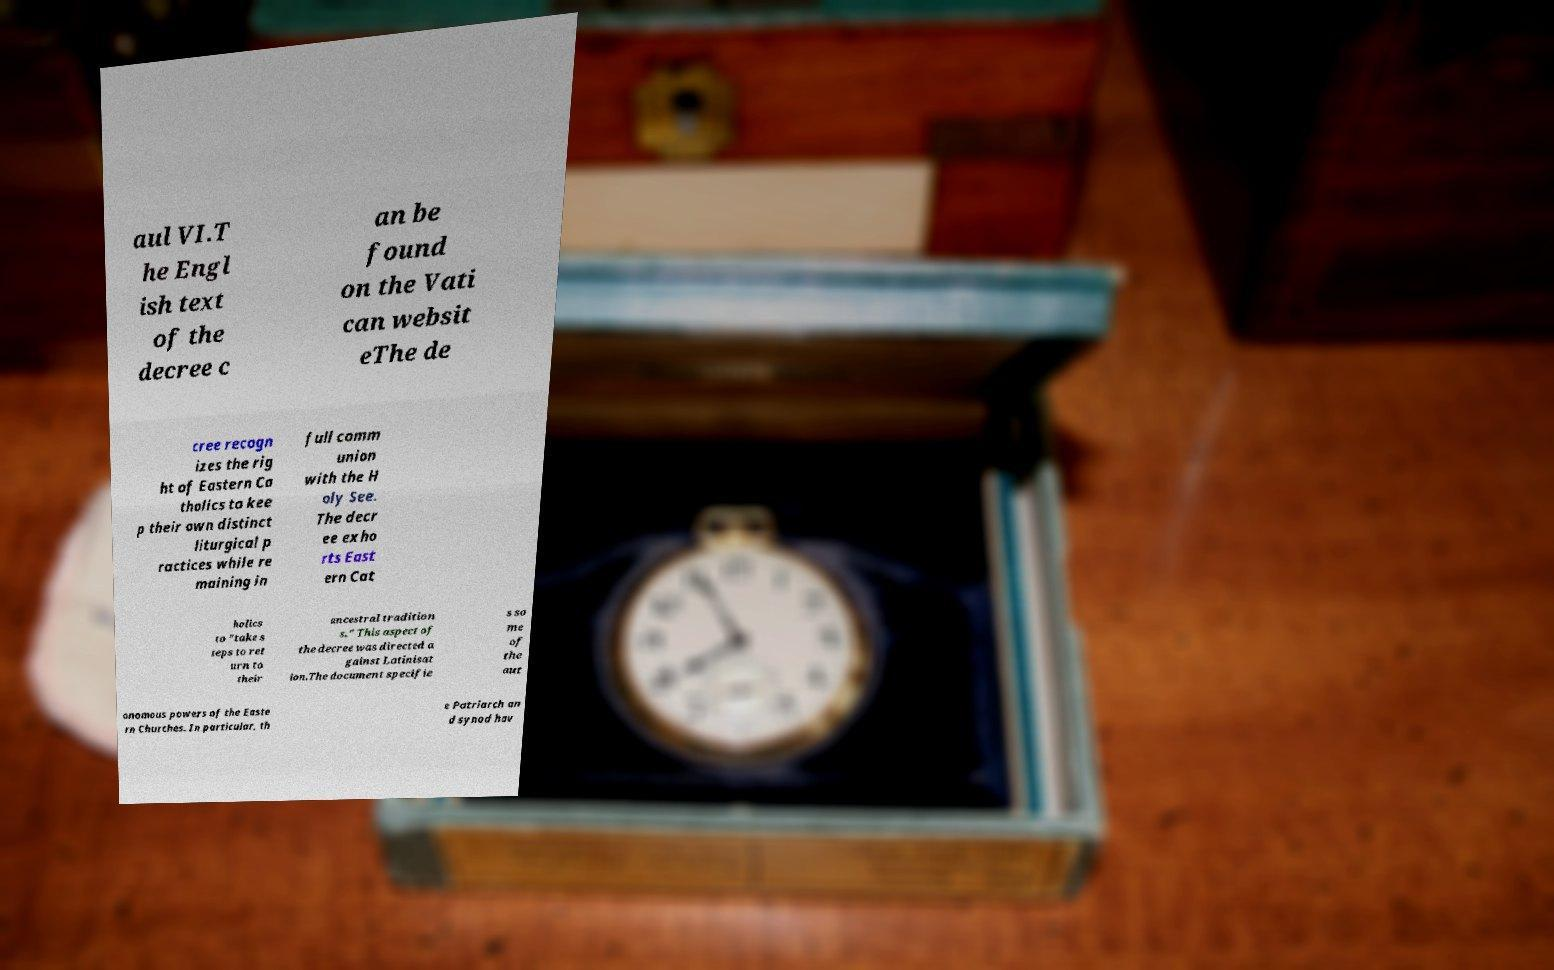Could you extract and type out the text from this image? aul VI.T he Engl ish text of the decree c an be found on the Vati can websit eThe de cree recogn izes the rig ht of Eastern Ca tholics to kee p their own distinct liturgical p ractices while re maining in full comm union with the H oly See. The decr ee exho rts East ern Cat holics to "take s teps to ret urn to their ancestral tradition s." This aspect of the decree was directed a gainst Latinisat ion.The document specifie s so me of the aut onomous powers of the Easte rn Churches. In particular, th e Patriarch an d synod hav 